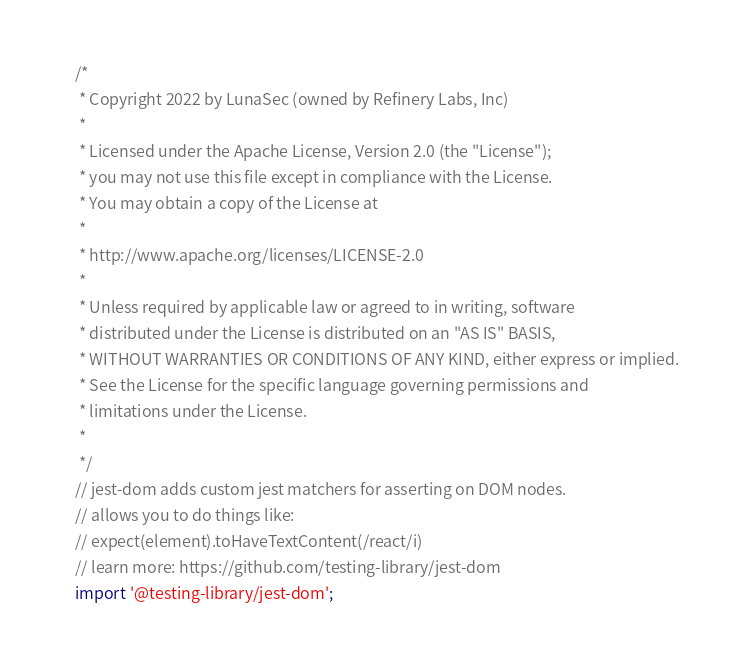<code> <loc_0><loc_0><loc_500><loc_500><_TypeScript_>/*
 * Copyright 2022 by LunaSec (owned by Refinery Labs, Inc)
 *
 * Licensed under the Apache License, Version 2.0 (the "License");
 * you may not use this file except in compliance with the License.
 * You may obtain a copy of the License at
 *
 * http://www.apache.org/licenses/LICENSE-2.0
 *
 * Unless required by applicable law or agreed to in writing, software
 * distributed under the License is distributed on an "AS IS" BASIS,
 * WITHOUT WARRANTIES OR CONDITIONS OF ANY KIND, either express or implied.
 * See the License for the specific language governing permissions and
 * limitations under the License.
 *
 */
// jest-dom adds custom jest matchers for asserting on DOM nodes.
// allows you to do things like:
// expect(element).toHaveTextContent(/react/i)
// learn more: https://github.com/testing-library/jest-dom
import '@testing-library/jest-dom';
</code> 